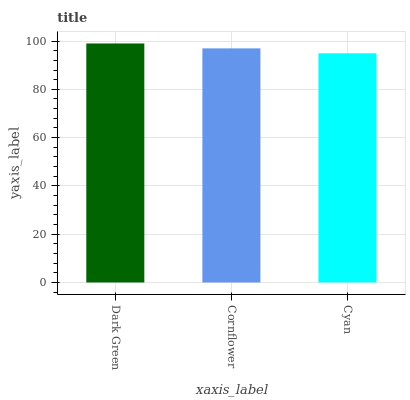Is Cornflower the minimum?
Answer yes or no. No. Is Cornflower the maximum?
Answer yes or no. No. Is Dark Green greater than Cornflower?
Answer yes or no. Yes. Is Cornflower less than Dark Green?
Answer yes or no. Yes. Is Cornflower greater than Dark Green?
Answer yes or no. No. Is Dark Green less than Cornflower?
Answer yes or no. No. Is Cornflower the high median?
Answer yes or no. Yes. Is Cornflower the low median?
Answer yes or no. Yes. Is Cyan the high median?
Answer yes or no. No. Is Dark Green the low median?
Answer yes or no. No. 